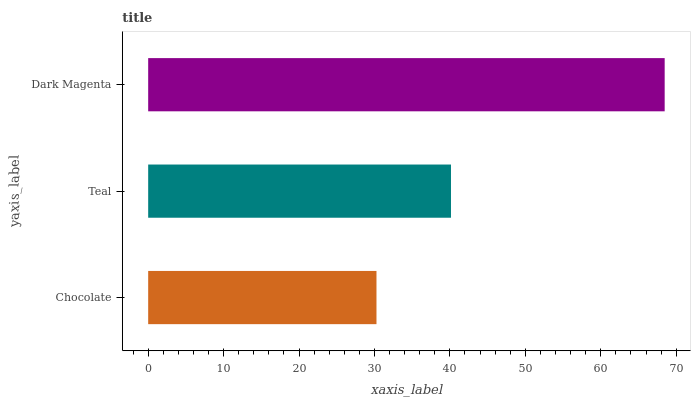Is Chocolate the minimum?
Answer yes or no. Yes. Is Dark Magenta the maximum?
Answer yes or no. Yes. Is Teal the minimum?
Answer yes or no. No. Is Teal the maximum?
Answer yes or no. No. Is Teal greater than Chocolate?
Answer yes or no. Yes. Is Chocolate less than Teal?
Answer yes or no. Yes. Is Chocolate greater than Teal?
Answer yes or no. No. Is Teal less than Chocolate?
Answer yes or no. No. Is Teal the high median?
Answer yes or no. Yes. Is Teal the low median?
Answer yes or no. Yes. Is Dark Magenta the high median?
Answer yes or no. No. Is Dark Magenta the low median?
Answer yes or no. No. 